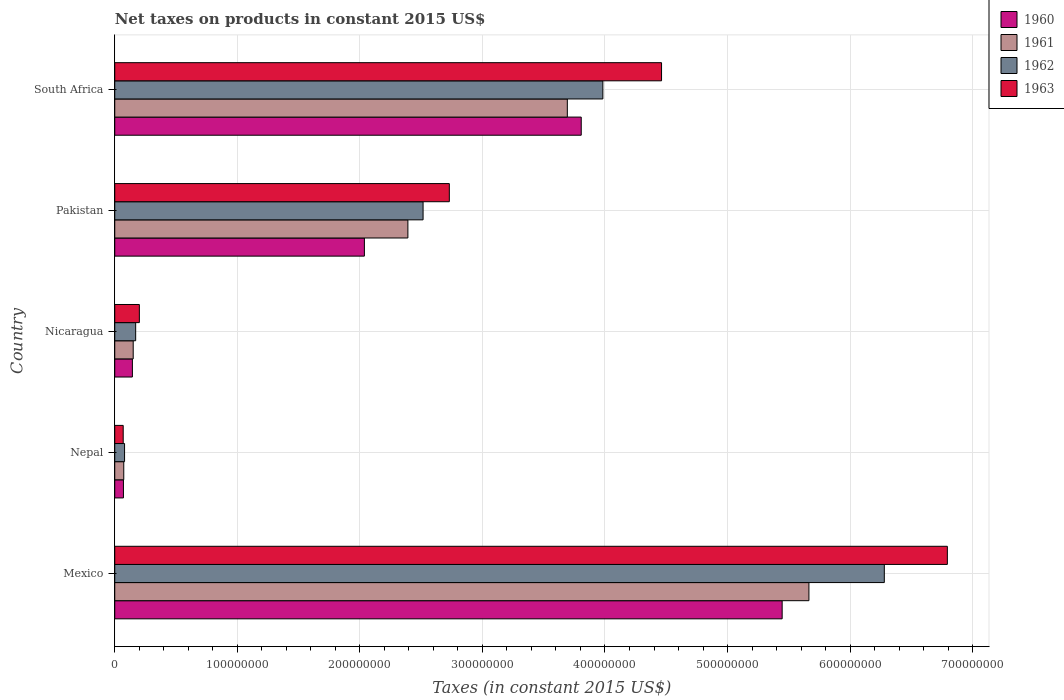How many different coloured bars are there?
Offer a very short reply. 4. How many bars are there on the 5th tick from the bottom?
Offer a very short reply. 4. What is the net taxes on products in 1961 in Pakistan?
Provide a succinct answer. 2.39e+08. Across all countries, what is the maximum net taxes on products in 1961?
Make the answer very short. 5.66e+08. Across all countries, what is the minimum net taxes on products in 1963?
Provide a succinct answer. 6.89e+06. In which country was the net taxes on products in 1961 minimum?
Offer a terse response. Nepal. What is the total net taxes on products in 1962 in the graph?
Provide a succinct answer. 1.30e+09. What is the difference between the net taxes on products in 1960 in Mexico and that in Nicaragua?
Give a very brief answer. 5.30e+08. What is the difference between the net taxes on products in 1961 in Nepal and the net taxes on products in 1960 in Pakistan?
Provide a short and direct response. -1.96e+08. What is the average net taxes on products in 1962 per country?
Your answer should be very brief. 2.61e+08. What is the difference between the net taxes on products in 1963 and net taxes on products in 1962 in South Africa?
Ensure brevity in your answer.  4.79e+07. In how many countries, is the net taxes on products in 1962 greater than 420000000 US$?
Offer a terse response. 1. What is the ratio of the net taxes on products in 1962 in Mexico to that in Pakistan?
Offer a very short reply. 2.5. Is the difference between the net taxes on products in 1963 in Pakistan and South Africa greater than the difference between the net taxes on products in 1962 in Pakistan and South Africa?
Give a very brief answer. No. What is the difference between the highest and the second highest net taxes on products in 1961?
Give a very brief answer. 1.97e+08. What is the difference between the highest and the lowest net taxes on products in 1962?
Provide a short and direct response. 6.20e+08. Is the sum of the net taxes on products in 1961 in Nicaragua and South Africa greater than the maximum net taxes on products in 1960 across all countries?
Provide a succinct answer. No. Is it the case that in every country, the sum of the net taxes on products in 1961 and net taxes on products in 1962 is greater than the sum of net taxes on products in 1963 and net taxes on products in 1960?
Offer a terse response. No. What does the 4th bar from the bottom in Pakistan represents?
Make the answer very short. 1963. How many bars are there?
Provide a succinct answer. 20. Are all the bars in the graph horizontal?
Your answer should be very brief. Yes. How many countries are there in the graph?
Ensure brevity in your answer.  5. What is the difference between two consecutive major ticks on the X-axis?
Make the answer very short. 1.00e+08. Does the graph contain any zero values?
Your answer should be compact. No. How many legend labels are there?
Give a very brief answer. 4. How are the legend labels stacked?
Your answer should be compact. Vertical. What is the title of the graph?
Your response must be concise. Net taxes on products in constant 2015 US$. Does "1976" appear as one of the legend labels in the graph?
Provide a succinct answer. No. What is the label or title of the X-axis?
Keep it short and to the point. Taxes (in constant 2015 US$). What is the label or title of the Y-axis?
Keep it short and to the point. Country. What is the Taxes (in constant 2015 US$) of 1960 in Mexico?
Provide a short and direct response. 5.45e+08. What is the Taxes (in constant 2015 US$) in 1961 in Mexico?
Ensure brevity in your answer.  5.66e+08. What is the Taxes (in constant 2015 US$) in 1962 in Mexico?
Ensure brevity in your answer.  6.28e+08. What is the Taxes (in constant 2015 US$) of 1963 in Mexico?
Your response must be concise. 6.79e+08. What is the Taxes (in constant 2015 US$) of 1960 in Nepal?
Provide a succinct answer. 7.09e+06. What is the Taxes (in constant 2015 US$) of 1961 in Nepal?
Offer a terse response. 7.35e+06. What is the Taxes (in constant 2015 US$) in 1962 in Nepal?
Offer a terse response. 8.01e+06. What is the Taxes (in constant 2015 US$) of 1963 in Nepal?
Offer a very short reply. 6.89e+06. What is the Taxes (in constant 2015 US$) in 1960 in Nicaragua?
Your answer should be compact. 1.44e+07. What is the Taxes (in constant 2015 US$) of 1961 in Nicaragua?
Make the answer very short. 1.51e+07. What is the Taxes (in constant 2015 US$) in 1962 in Nicaragua?
Keep it short and to the point. 1.71e+07. What is the Taxes (in constant 2015 US$) of 1963 in Nicaragua?
Give a very brief answer. 2.01e+07. What is the Taxes (in constant 2015 US$) in 1960 in Pakistan?
Give a very brief answer. 2.04e+08. What is the Taxes (in constant 2015 US$) of 1961 in Pakistan?
Give a very brief answer. 2.39e+08. What is the Taxes (in constant 2015 US$) in 1962 in Pakistan?
Your response must be concise. 2.52e+08. What is the Taxes (in constant 2015 US$) of 1963 in Pakistan?
Make the answer very short. 2.73e+08. What is the Taxes (in constant 2015 US$) of 1960 in South Africa?
Give a very brief answer. 3.81e+08. What is the Taxes (in constant 2015 US$) in 1961 in South Africa?
Give a very brief answer. 3.69e+08. What is the Taxes (in constant 2015 US$) in 1962 in South Africa?
Provide a short and direct response. 3.98e+08. What is the Taxes (in constant 2015 US$) in 1963 in South Africa?
Make the answer very short. 4.46e+08. Across all countries, what is the maximum Taxes (in constant 2015 US$) in 1960?
Give a very brief answer. 5.45e+08. Across all countries, what is the maximum Taxes (in constant 2015 US$) in 1961?
Keep it short and to the point. 5.66e+08. Across all countries, what is the maximum Taxes (in constant 2015 US$) in 1962?
Your answer should be compact. 6.28e+08. Across all countries, what is the maximum Taxes (in constant 2015 US$) in 1963?
Your answer should be very brief. 6.79e+08. Across all countries, what is the minimum Taxes (in constant 2015 US$) in 1960?
Give a very brief answer. 7.09e+06. Across all countries, what is the minimum Taxes (in constant 2015 US$) of 1961?
Provide a succinct answer. 7.35e+06. Across all countries, what is the minimum Taxes (in constant 2015 US$) of 1962?
Provide a short and direct response. 8.01e+06. Across all countries, what is the minimum Taxes (in constant 2015 US$) in 1963?
Offer a terse response. 6.89e+06. What is the total Taxes (in constant 2015 US$) in 1960 in the graph?
Provide a succinct answer. 1.15e+09. What is the total Taxes (in constant 2015 US$) in 1961 in the graph?
Your answer should be compact. 1.20e+09. What is the total Taxes (in constant 2015 US$) in 1962 in the graph?
Your answer should be compact. 1.30e+09. What is the total Taxes (in constant 2015 US$) in 1963 in the graph?
Give a very brief answer. 1.43e+09. What is the difference between the Taxes (in constant 2015 US$) of 1960 in Mexico and that in Nepal?
Provide a succinct answer. 5.37e+08. What is the difference between the Taxes (in constant 2015 US$) of 1961 in Mexico and that in Nepal?
Provide a succinct answer. 5.59e+08. What is the difference between the Taxes (in constant 2015 US$) in 1962 in Mexico and that in Nepal?
Your response must be concise. 6.20e+08. What is the difference between the Taxes (in constant 2015 US$) of 1963 in Mexico and that in Nepal?
Make the answer very short. 6.72e+08. What is the difference between the Taxes (in constant 2015 US$) of 1960 in Mexico and that in Nicaragua?
Your answer should be compact. 5.30e+08. What is the difference between the Taxes (in constant 2015 US$) in 1961 in Mexico and that in Nicaragua?
Offer a very short reply. 5.51e+08. What is the difference between the Taxes (in constant 2015 US$) of 1962 in Mexico and that in Nicaragua?
Offer a terse response. 6.11e+08. What is the difference between the Taxes (in constant 2015 US$) in 1963 in Mexico and that in Nicaragua?
Give a very brief answer. 6.59e+08. What is the difference between the Taxes (in constant 2015 US$) of 1960 in Mexico and that in Pakistan?
Your answer should be very brief. 3.41e+08. What is the difference between the Taxes (in constant 2015 US$) of 1961 in Mexico and that in Pakistan?
Give a very brief answer. 3.27e+08. What is the difference between the Taxes (in constant 2015 US$) in 1962 in Mexico and that in Pakistan?
Ensure brevity in your answer.  3.76e+08. What is the difference between the Taxes (in constant 2015 US$) in 1963 in Mexico and that in Pakistan?
Provide a short and direct response. 4.06e+08. What is the difference between the Taxes (in constant 2015 US$) in 1960 in Mexico and that in South Africa?
Provide a short and direct response. 1.64e+08. What is the difference between the Taxes (in constant 2015 US$) in 1961 in Mexico and that in South Africa?
Your answer should be compact. 1.97e+08. What is the difference between the Taxes (in constant 2015 US$) in 1962 in Mexico and that in South Africa?
Offer a very short reply. 2.30e+08. What is the difference between the Taxes (in constant 2015 US$) in 1963 in Mexico and that in South Africa?
Offer a very short reply. 2.33e+08. What is the difference between the Taxes (in constant 2015 US$) of 1960 in Nepal and that in Nicaragua?
Provide a short and direct response. -7.30e+06. What is the difference between the Taxes (in constant 2015 US$) of 1961 in Nepal and that in Nicaragua?
Provide a short and direct response. -7.71e+06. What is the difference between the Taxes (in constant 2015 US$) of 1962 in Nepal and that in Nicaragua?
Make the answer very short. -9.06e+06. What is the difference between the Taxes (in constant 2015 US$) of 1963 in Nepal and that in Nicaragua?
Provide a succinct answer. -1.32e+07. What is the difference between the Taxes (in constant 2015 US$) of 1960 in Nepal and that in Pakistan?
Your answer should be compact. -1.97e+08. What is the difference between the Taxes (in constant 2015 US$) in 1961 in Nepal and that in Pakistan?
Give a very brief answer. -2.32e+08. What is the difference between the Taxes (in constant 2015 US$) in 1962 in Nepal and that in Pakistan?
Provide a succinct answer. -2.44e+08. What is the difference between the Taxes (in constant 2015 US$) of 1963 in Nepal and that in Pakistan?
Give a very brief answer. -2.66e+08. What is the difference between the Taxes (in constant 2015 US$) of 1960 in Nepal and that in South Africa?
Offer a very short reply. -3.74e+08. What is the difference between the Taxes (in constant 2015 US$) in 1961 in Nepal and that in South Africa?
Offer a terse response. -3.62e+08. What is the difference between the Taxes (in constant 2015 US$) of 1962 in Nepal and that in South Africa?
Keep it short and to the point. -3.90e+08. What is the difference between the Taxes (in constant 2015 US$) of 1963 in Nepal and that in South Africa?
Make the answer very short. -4.39e+08. What is the difference between the Taxes (in constant 2015 US$) in 1960 in Nicaragua and that in Pakistan?
Your response must be concise. -1.89e+08. What is the difference between the Taxes (in constant 2015 US$) in 1961 in Nicaragua and that in Pakistan?
Keep it short and to the point. -2.24e+08. What is the difference between the Taxes (in constant 2015 US$) in 1962 in Nicaragua and that in Pakistan?
Make the answer very short. -2.35e+08. What is the difference between the Taxes (in constant 2015 US$) of 1963 in Nicaragua and that in Pakistan?
Offer a terse response. -2.53e+08. What is the difference between the Taxes (in constant 2015 US$) of 1960 in Nicaragua and that in South Africa?
Offer a terse response. -3.66e+08. What is the difference between the Taxes (in constant 2015 US$) in 1961 in Nicaragua and that in South Africa?
Offer a terse response. -3.54e+08. What is the difference between the Taxes (in constant 2015 US$) in 1962 in Nicaragua and that in South Africa?
Ensure brevity in your answer.  -3.81e+08. What is the difference between the Taxes (in constant 2015 US$) in 1963 in Nicaragua and that in South Africa?
Your response must be concise. -4.26e+08. What is the difference between the Taxes (in constant 2015 US$) in 1960 in Pakistan and that in South Africa?
Give a very brief answer. -1.77e+08. What is the difference between the Taxes (in constant 2015 US$) in 1961 in Pakistan and that in South Africa?
Give a very brief answer. -1.30e+08. What is the difference between the Taxes (in constant 2015 US$) of 1962 in Pakistan and that in South Africa?
Ensure brevity in your answer.  -1.47e+08. What is the difference between the Taxes (in constant 2015 US$) of 1963 in Pakistan and that in South Africa?
Provide a short and direct response. -1.73e+08. What is the difference between the Taxes (in constant 2015 US$) of 1960 in Mexico and the Taxes (in constant 2015 US$) of 1961 in Nepal?
Ensure brevity in your answer.  5.37e+08. What is the difference between the Taxes (in constant 2015 US$) of 1960 in Mexico and the Taxes (in constant 2015 US$) of 1962 in Nepal?
Your answer should be compact. 5.37e+08. What is the difference between the Taxes (in constant 2015 US$) in 1960 in Mexico and the Taxes (in constant 2015 US$) in 1963 in Nepal?
Make the answer very short. 5.38e+08. What is the difference between the Taxes (in constant 2015 US$) in 1961 in Mexico and the Taxes (in constant 2015 US$) in 1962 in Nepal?
Offer a very short reply. 5.58e+08. What is the difference between the Taxes (in constant 2015 US$) of 1961 in Mexico and the Taxes (in constant 2015 US$) of 1963 in Nepal?
Your answer should be compact. 5.60e+08. What is the difference between the Taxes (in constant 2015 US$) of 1962 in Mexico and the Taxes (in constant 2015 US$) of 1963 in Nepal?
Make the answer very short. 6.21e+08. What is the difference between the Taxes (in constant 2015 US$) in 1960 in Mexico and the Taxes (in constant 2015 US$) in 1961 in Nicaragua?
Provide a succinct answer. 5.30e+08. What is the difference between the Taxes (in constant 2015 US$) in 1960 in Mexico and the Taxes (in constant 2015 US$) in 1962 in Nicaragua?
Provide a succinct answer. 5.28e+08. What is the difference between the Taxes (in constant 2015 US$) in 1960 in Mexico and the Taxes (in constant 2015 US$) in 1963 in Nicaragua?
Ensure brevity in your answer.  5.24e+08. What is the difference between the Taxes (in constant 2015 US$) in 1961 in Mexico and the Taxes (in constant 2015 US$) in 1962 in Nicaragua?
Offer a terse response. 5.49e+08. What is the difference between the Taxes (in constant 2015 US$) in 1961 in Mexico and the Taxes (in constant 2015 US$) in 1963 in Nicaragua?
Make the answer very short. 5.46e+08. What is the difference between the Taxes (in constant 2015 US$) in 1962 in Mexico and the Taxes (in constant 2015 US$) in 1963 in Nicaragua?
Your response must be concise. 6.08e+08. What is the difference between the Taxes (in constant 2015 US$) of 1960 in Mexico and the Taxes (in constant 2015 US$) of 1961 in Pakistan?
Provide a succinct answer. 3.05e+08. What is the difference between the Taxes (in constant 2015 US$) of 1960 in Mexico and the Taxes (in constant 2015 US$) of 1962 in Pakistan?
Your answer should be very brief. 2.93e+08. What is the difference between the Taxes (in constant 2015 US$) in 1960 in Mexico and the Taxes (in constant 2015 US$) in 1963 in Pakistan?
Give a very brief answer. 2.72e+08. What is the difference between the Taxes (in constant 2015 US$) of 1961 in Mexico and the Taxes (in constant 2015 US$) of 1962 in Pakistan?
Your response must be concise. 3.15e+08. What is the difference between the Taxes (in constant 2015 US$) of 1961 in Mexico and the Taxes (in constant 2015 US$) of 1963 in Pakistan?
Provide a succinct answer. 2.93e+08. What is the difference between the Taxes (in constant 2015 US$) of 1962 in Mexico and the Taxes (in constant 2015 US$) of 1963 in Pakistan?
Your answer should be very brief. 3.55e+08. What is the difference between the Taxes (in constant 2015 US$) of 1960 in Mexico and the Taxes (in constant 2015 US$) of 1961 in South Africa?
Provide a succinct answer. 1.75e+08. What is the difference between the Taxes (in constant 2015 US$) in 1960 in Mexico and the Taxes (in constant 2015 US$) in 1962 in South Africa?
Ensure brevity in your answer.  1.46e+08. What is the difference between the Taxes (in constant 2015 US$) in 1960 in Mexico and the Taxes (in constant 2015 US$) in 1963 in South Africa?
Offer a very short reply. 9.84e+07. What is the difference between the Taxes (in constant 2015 US$) in 1961 in Mexico and the Taxes (in constant 2015 US$) in 1962 in South Africa?
Offer a very short reply. 1.68e+08. What is the difference between the Taxes (in constant 2015 US$) in 1961 in Mexico and the Taxes (in constant 2015 US$) in 1963 in South Africa?
Provide a short and direct response. 1.20e+08. What is the difference between the Taxes (in constant 2015 US$) in 1962 in Mexico and the Taxes (in constant 2015 US$) in 1963 in South Africa?
Keep it short and to the point. 1.82e+08. What is the difference between the Taxes (in constant 2015 US$) in 1960 in Nepal and the Taxes (in constant 2015 US$) in 1961 in Nicaragua?
Your response must be concise. -7.97e+06. What is the difference between the Taxes (in constant 2015 US$) of 1960 in Nepal and the Taxes (in constant 2015 US$) of 1962 in Nicaragua?
Provide a short and direct response. -9.98e+06. What is the difference between the Taxes (in constant 2015 US$) in 1960 in Nepal and the Taxes (in constant 2015 US$) in 1963 in Nicaragua?
Ensure brevity in your answer.  -1.30e+07. What is the difference between the Taxes (in constant 2015 US$) of 1961 in Nepal and the Taxes (in constant 2015 US$) of 1962 in Nicaragua?
Your answer should be compact. -9.71e+06. What is the difference between the Taxes (in constant 2015 US$) in 1961 in Nepal and the Taxes (in constant 2015 US$) in 1963 in Nicaragua?
Provide a succinct answer. -1.27e+07. What is the difference between the Taxes (in constant 2015 US$) of 1962 in Nepal and the Taxes (in constant 2015 US$) of 1963 in Nicaragua?
Provide a short and direct response. -1.21e+07. What is the difference between the Taxes (in constant 2015 US$) of 1960 in Nepal and the Taxes (in constant 2015 US$) of 1961 in Pakistan?
Your response must be concise. -2.32e+08. What is the difference between the Taxes (in constant 2015 US$) in 1960 in Nepal and the Taxes (in constant 2015 US$) in 1962 in Pakistan?
Make the answer very short. -2.44e+08. What is the difference between the Taxes (in constant 2015 US$) of 1960 in Nepal and the Taxes (in constant 2015 US$) of 1963 in Pakistan?
Provide a succinct answer. -2.66e+08. What is the difference between the Taxes (in constant 2015 US$) of 1961 in Nepal and the Taxes (in constant 2015 US$) of 1962 in Pakistan?
Give a very brief answer. -2.44e+08. What is the difference between the Taxes (in constant 2015 US$) of 1961 in Nepal and the Taxes (in constant 2015 US$) of 1963 in Pakistan?
Offer a very short reply. -2.66e+08. What is the difference between the Taxes (in constant 2015 US$) of 1962 in Nepal and the Taxes (in constant 2015 US$) of 1963 in Pakistan?
Give a very brief answer. -2.65e+08. What is the difference between the Taxes (in constant 2015 US$) of 1960 in Nepal and the Taxes (in constant 2015 US$) of 1961 in South Africa?
Provide a short and direct response. -3.62e+08. What is the difference between the Taxes (in constant 2015 US$) of 1960 in Nepal and the Taxes (in constant 2015 US$) of 1962 in South Africa?
Your answer should be very brief. -3.91e+08. What is the difference between the Taxes (in constant 2015 US$) in 1960 in Nepal and the Taxes (in constant 2015 US$) in 1963 in South Africa?
Provide a succinct answer. -4.39e+08. What is the difference between the Taxes (in constant 2015 US$) in 1961 in Nepal and the Taxes (in constant 2015 US$) in 1962 in South Africa?
Offer a very short reply. -3.91e+08. What is the difference between the Taxes (in constant 2015 US$) in 1961 in Nepal and the Taxes (in constant 2015 US$) in 1963 in South Africa?
Provide a succinct answer. -4.39e+08. What is the difference between the Taxes (in constant 2015 US$) in 1962 in Nepal and the Taxes (in constant 2015 US$) in 1963 in South Africa?
Offer a very short reply. -4.38e+08. What is the difference between the Taxes (in constant 2015 US$) in 1960 in Nicaragua and the Taxes (in constant 2015 US$) in 1961 in Pakistan?
Give a very brief answer. -2.25e+08. What is the difference between the Taxes (in constant 2015 US$) in 1960 in Nicaragua and the Taxes (in constant 2015 US$) in 1962 in Pakistan?
Offer a very short reply. -2.37e+08. What is the difference between the Taxes (in constant 2015 US$) in 1960 in Nicaragua and the Taxes (in constant 2015 US$) in 1963 in Pakistan?
Provide a short and direct response. -2.59e+08. What is the difference between the Taxes (in constant 2015 US$) in 1961 in Nicaragua and the Taxes (in constant 2015 US$) in 1962 in Pakistan?
Make the answer very short. -2.37e+08. What is the difference between the Taxes (in constant 2015 US$) of 1961 in Nicaragua and the Taxes (in constant 2015 US$) of 1963 in Pakistan?
Provide a short and direct response. -2.58e+08. What is the difference between the Taxes (in constant 2015 US$) of 1962 in Nicaragua and the Taxes (in constant 2015 US$) of 1963 in Pakistan?
Your answer should be very brief. -2.56e+08. What is the difference between the Taxes (in constant 2015 US$) in 1960 in Nicaragua and the Taxes (in constant 2015 US$) in 1961 in South Africa?
Provide a succinct answer. -3.55e+08. What is the difference between the Taxes (in constant 2015 US$) in 1960 in Nicaragua and the Taxes (in constant 2015 US$) in 1962 in South Africa?
Your response must be concise. -3.84e+08. What is the difference between the Taxes (in constant 2015 US$) of 1960 in Nicaragua and the Taxes (in constant 2015 US$) of 1963 in South Africa?
Your answer should be compact. -4.32e+08. What is the difference between the Taxes (in constant 2015 US$) in 1961 in Nicaragua and the Taxes (in constant 2015 US$) in 1962 in South Africa?
Provide a short and direct response. -3.83e+08. What is the difference between the Taxes (in constant 2015 US$) of 1961 in Nicaragua and the Taxes (in constant 2015 US$) of 1963 in South Africa?
Give a very brief answer. -4.31e+08. What is the difference between the Taxes (in constant 2015 US$) of 1962 in Nicaragua and the Taxes (in constant 2015 US$) of 1963 in South Africa?
Provide a succinct answer. -4.29e+08. What is the difference between the Taxes (in constant 2015 US$) in 1960 in Pakistan and the Taxes (in constant 2015 US$) in 1961 in South Africa?
Your answer should be compact. -1.66e+08. What is the difference between the Taxes (in constant 2015 US$) of 1960 in Pakistan and the Taxes (in constant 2015 US$) of 1962 in South Africa?
Ensure brevity in your answer.  -1.95e+08. What is the difference between the Taxes (in constant 2015 US$) of 1960 in Pakistan and the Taxes (in constant 2015 US$) of 1963 in South Africa?
Keep it short and to the point. -2.42e+08. What is the difference between the Taxes (in constant 2015 US$) in 1961 in Pakistan and the Taxes (in constant 2015 US$) in 1962 in South Africa?
Provide a succinct answer. -1.59e+08. What is the difference between the Taxes (in constant 2015 US$) in 1961 in Pakistan and the Taxes (in constant 2015 US$) in 1963 in South Africa?
Your answer should be very brief. -2.07e+08. What is the difference between the Taxes (in constant 2015 US$) of 1962 in Pakistan and the Taxes (in constant 2015 US$) of 1963 in South Africa?
Give a very brief answer. -1.95e+08. What is the average Taxes (in constant 2015 US$) of 1960 per country?
Keep it short and to the point. 2.30e+08. What is the average Taxes (in constant 2015 US$) in 1961 per country?
Keep it short and to the point. 2.39e+08. What is the average Taxes (in constant 2015 US$) in 1962 per country?
Make the answer very short. 2.61e+08. What is the average Taxes (in constant 2015 US$) of 1963 per country?
Your response must be concise. 2.85e+08. What is the difference between the Taxes (in constant 2015 US$) of 1960 and Taxes (in constant 2015 US$) of 1961 in Mexico?
Provide a succinct answer. -2.18e+07. What is the difference between the Taxes (in constant 2015 US$) of 1960 and Taxes (in constant 2015 US$) of 1962 in Mexico?
Provide a short and direct response. -8.34e+07. What is the difference between the Taxes (in constant 2015 US$) in 1960 and Taxes (in constant 2015 US$) in 1963 in Mexico?
Your answer should be compact. -1.35e+08. What is the difference between the Taxes (in constant 2015 US$) of 1961 and Taxes (in constant 2015 US$) of 1962 in Mexico?
Ensure brevity in your answer.  -6.15e+07. What is the difference between the Taxes (in constant 2015 US$) in 1961 and Taxes (in constant 2015 US$) in 1963 in Mexico?
Keep it short and to the point. -1.13e+08. What is the difference between the Taxes (in constant 2015 US$) in 1962 and Taxes (in constant 2015 US$) in 1963 in Mexico?
Make the answer very short. -5.14e+07. What is the difference between the Taxes (in constant 2015 US$) in 1960 and Taxes (in constant 2015 US$) in 1961 in Nepal?
Keep it short and to the point. -2.63e+05. What is the difference between the Taxes (in constant 2015 US$) of 1960 and Taxes (in constant 2015 US$) of 1962 in Nepal?
Your answer should be very brief. -9.19e+05. What is the difference between the Taxes (in constant 2015 US$) of 1960 and Taxes (in constant 2015 US$) of 1963 in Nepal?
Offer a terse response. 1.97e+05. What is the difference between the Taxes (in constant 2015 US$) of 1961 and Taxes (in constant 2015 US$) of 1962 in Nepal?
Keep it short and to the point. -6.56e+05. What is the difference between the Taxes (in constant 2015 US$) in 1961 and Taxes (in constant 2015 US$) in 1963 in Nepal?
Your answer should be very brief. 4.60e+05. What is the difference between the Taxes (in constant 2015 US$) of 1962 and Taxes (in constant 2015 US$) of 1963 in Nepal?
Offer a very short reply. 1.12e+06. What is the difference between the Taxes (in constant 2015 US$) in 1960 and Taxes (in constant 2015 US$) in 1961 in Nicaragua?
Offer a very short reply. -6.69e+05. What is the difference between the Taxes (in constant 2015 US$) of 1960 and Taxes (in constant 2015 US$) of 1962 in Nicaragua?
Keep it short and to the point. -2.68e+06. What is the difference between the Taxes (in constant 2015 US$) of 1960 and Taxes (in constant 2015 US$) of 1963 in Nicaragua?
Your answer should be compact. -5.69e+06. What is the difference between the Taxes (in constant 2015 US$) in 1961 and Taxes (in constant 2015 US$) in 1962 in Nicaragua?
Provide a succinct answer. -2.01e+06. What is the difference between the Taxes (in constant 2015 US$) in 1961 and Taxes (in constant 2015 US$) in 1963 in Nicaragua?
Provide a short and direct response. -5.02e+06. What is the difference between the Taxes (in constant 2015 US$) of 1962 and Taxes (in constant 2015 US$) of 1963 in Nicaragua?
Provide a succinct answer. -3.01e+06. What is the difference between the Taxes (in constant 2015 US$) of 1960 and Taxes (in constant 2015 US$) of 1961 in Pakistan?
Ensure brevity in your answer.  -3.55e+07. What is the difference between the Taxes (in constant 2015 US$) in 1960 and Taxes (in constant 2015 US$) in 1962 in Pakistan?
Provide a short and direct response. -4.79e+07. What is the difference between the Taxes (in constant 2015 US$) of 1960 and Taxes (in constant 2015 US$) of 1963 in Pakistan?
Keep it short and to the point. -6.93e+07. What is the difference between the Taxes (in constant 2015 US$) in 1961 and Taxes (in constant 2015 US$) in 1962 in Pakistan?
Your response must be concise. -1.24e+07. What is the difference between the Taxes (in constant 2015 US$) in 1961 and Taxes (in constant 2015 US$) in 1963 in Pakistan?
Offer a terse response. -3.38e+07. What is the difference between the Taxes (in constant 2015 US$) of 1962 and Taxes (in constant 2015 US$) of 1963 in Pakistan?
Your answer should be very brief. -2.14e+07. What is the difference between the Taxes (in constant 2015 US$) of 1960 and Taxes (in constant 2015 US$) of 1961 in South Africa?
Offer a very short reply. 1.13e+07. What is the difference between the Taxes (in constant 2015 US$) in 1960 and Taxes (in constant 2015 US$) in 1962 in South Africa?
Your answer should be very brief. -1.76e+07. What is the difference between the Taxes (in constant 2015 US$) in 1960 and Taxes (in constant 2015 US$) in 1963 in South Africa?
Your response must be concise. -6.55e+07. What is the difference between the Taxes (in constant 2015 US$) in 1961 and Taxes (in constant 2015 US$) in 1962 in South Africa?
Make the answer very short. -2.90e+07. What is the difference between the Taxes (in constant 2015 US$) of 1961 and Taxes (in constant 2015 US$) of 1963 in South Africa?
Make the answer very short. -7.69e+07. What is the difference between the Taxes (in constant 2015 US$) in 1962 and Taxes (in constant 2015 US$) in 1963 in South Africa?
Provide a succinct answer. -4.79e+07. What is the ratio of the Taxes (in constant 2015 US$) of 1960 in Mexico to that in Nepal?
Make the answer very short. 76.83. What is the ratio of the Taxes (in constant 2015 US$) in 1961 in Mexico to that in Nepal?
Your answer should be compact. 77.06. What is the ratio of the Taxes (in constant 2015 US$) of 1962 in Mexico to that in Nepal?
Ensure brevity in your answer.  78.43. What is the ratio of the Taxes (in constant 2015 US$) in 1963 in Mexico to that in Nepal?
Give a very brief answer. 98.6. What is the ratio of the Taxes (in constant 2015 US$) of 1960 in Mexico to that in Nicaragua?
Provide a succinct answer. 37.85. What is the ratio of the Taxes (in constant 2015 US$) of 1961 in Mexico to that in Nicaragua?
Offer a terse response. 37.62. What is the ratio of the Taxes (in constant 2015 US$) in 1962 in Mexico to that in Nicaragua?
Your response must be concise. 36.8. What is the ratio of the Taxes (in constant 2015 US$) of 1963 in Mexico to that in Nicaragua?
Give a very brief answer. 33.84. What is the ratio of the Taxes (in constant 2015 US$) of 1960 in Mexico to that in Pakistan?
Ensure brevity in your answer.  2.67. What is the ratio of the Taxes (in constant 2015 US$) of 1961 in Mexico to that in Pakistan?
Give a very brief answer. 2.37. What is the ratio of the Taxes (in constant 2015 US$) of 1962 in Mexico to that in Pakistan?
Ensure brevity in your answer.  2.5. What is the ratio of the Taxes (in constant 2015 US$) of 1963 in Mexico to that in Pakistan?
Your answer should be very brief. 2.49. What is the ratio of the Taxes (in constant 2015 US$) in 1960 in Mexico to that in South Africa?
Your answer should be compact. 1.43. What is the ratio of the Taxes (in constant 2015 US$) of 1961 in Mexico to that in South Africa?
Provide a short and direct response. 1.53. What is the ratio of the Taxes (in constant 2015 US$) of 1962 in Mexico to that in South Africa?
Make the answer very short. 1.58. What is the ratio of the Taxes (in constant 2015 US$) in 1963 in Mexico to that in South Africa?
Offer a terse response. 1.52. What is the ratio of the Taxes (in constant 2015 US$) of 1960 in Nepal to that in Nicaragua?
Your answer should be compact. 0.49. What is the ratio of the Taxes (in constant 2015 US$) of 1961 in Nepal to that in Nicaragua?
Provide a short and direct response. 0.49. What is the ratio of the Taxes (in constant 2015 US$) of 1962 in Nepal to that in Nicaragua?
Make the answer very short. 0.47. What is the ratio of the Taxes (in constant 2015 US$) in 1963 in Nepal to that in Nicaragua?
Your response must be concise. 0.34. What is the ratio of the Taxes (in constant 2015 US$) of 1960 in Nepal to that in Pakistan?
Offer a very short reply. 0.03. What is the ratio of the Taxes (in constant 2015 US$) of 1961 in Nepal to that in Pakistan?
Keep it short and to the point. 0.03. What is the ratio of the Taxes (in constant 2015 US$) of 1962 in Nepal to that in Pakistan?
Keep it short and to the point. 0.03. What is the ratio of the Taxes (in constant 2015 US$) of 1963 in Nepal to that in Pakistan?
Your answer should be very brief. 0.03. What is the ratio of the Taxes (in constant 2015 US$) in 1960 in Nepal to that in South Africa?
Your response must be concise. 0.02. What is the ratio of the Taxes (in constant 2015 US$) of 1961 in Nepal to that in South Africa?
Keep it short and to the point. 0.02. What is the ratio of the Taxes (in constant 2015 US$) in 1962 in Nepal to that in South Africa?
Provide a short and direct response. 0.02. What is the ratio of the Taxes (in constant 2015 US$) of 1963 in Nepal to that in South Africa?
Make the answer very short. 0.02. What is the ratio of the Taxes (in constant 2015 US$) in 1960 in Nicaragua to that in Pakistan?
Provide a succinct answer. 0.07. What is the ratio of the Taxes (in constant 2015 US$) of 1961 in Nicaragua to that in Pakistan?
Provide a succinct answer. 0.06. What is the ratio of the Taxes (in constant 2015 US$) in 1962 in Nicaragua to that in Pakistan?
Provide a succinct answer. 0.07. What is the ratio of the Taxes (in constant 2015 US$) of 1963 in Nicaragua to that in Pakistan?
Offer a terse response. 0.07. What is the ratio of the Taxes (in constant 2015 US$) in 1960 in Nicaragua to that in South Africa?
Your response must be concise. 0.04. What is the ratio of the Taxes (in constant 2015 US$) of 1961 in Nicaragua to that in South Africa?
Make the answer very short. 0.04. What is the ratio of the Taxes (in constant 2015 US$) of 1962 in Nicaragua to that in South Africa?
Offer a terse response. 0.04. What is the ratio of the Taxes (in constant 2015 US$) in 1963 in Nicaragua to that in South Africa?
Your answer should be compact. 0.04. What is the ratio of the Taxes (in constant 2015 US$) of 1960 in Pakistan to that in South Africa?
Provide a succinct answer. 0.54. What is the ratio of the Taxes (in constant 2015 US$) in 1961 in Pakistan to that in South Africa?
Your answer should be very brief. 0.65. What is the ratio of the Taxes (in constant 2015 US$) in 1962 in Pakistan to that in South Africa?
Offer a terse response. 0.63. What is the ratio of the Taxes (in constant 2015 US$) of 1963 in Pakistan to that in South Africa?
Make the answer very short. 0.61. What is the difference between the highest and the second highest Taxes (in constant 2015 US$) of 1960?
Your response must be concise. 1.64e+08. What is the difference between the highest and the second highest Taxes (in constant 2015 US$) in 1961?
Your answer should be very brief. 1.97e+08. What is the difference between the highest and the second highest Taxes (in constant 2015 US$) in 1962?
Provide a succinct answer. 2.30e+08. What is the difference between the highest and the second highest Taxes (in constant 2015 US$) of 1963?
Your answer should be compact. 2.33e+08. What is the difference between the highest and the lowest Taxes (in constant 2015 US$) in 1960?
Keep it short and to the point. 5.37e+08. What is the difference between the highest and the lowest Taxes (in constant 2015 US$) in 1961?
Your answer should be very brief. 5.59e+08. What is the difference between the highest and the lowest Taxes (in constant 2015 US$) in 1962?
Make the answer very short. 6.20e+08. What is the difference between the highest and the lowest Taxes (in constant 2015 US$) in 1963?
Offer a very short reply. 6.72e+08. 